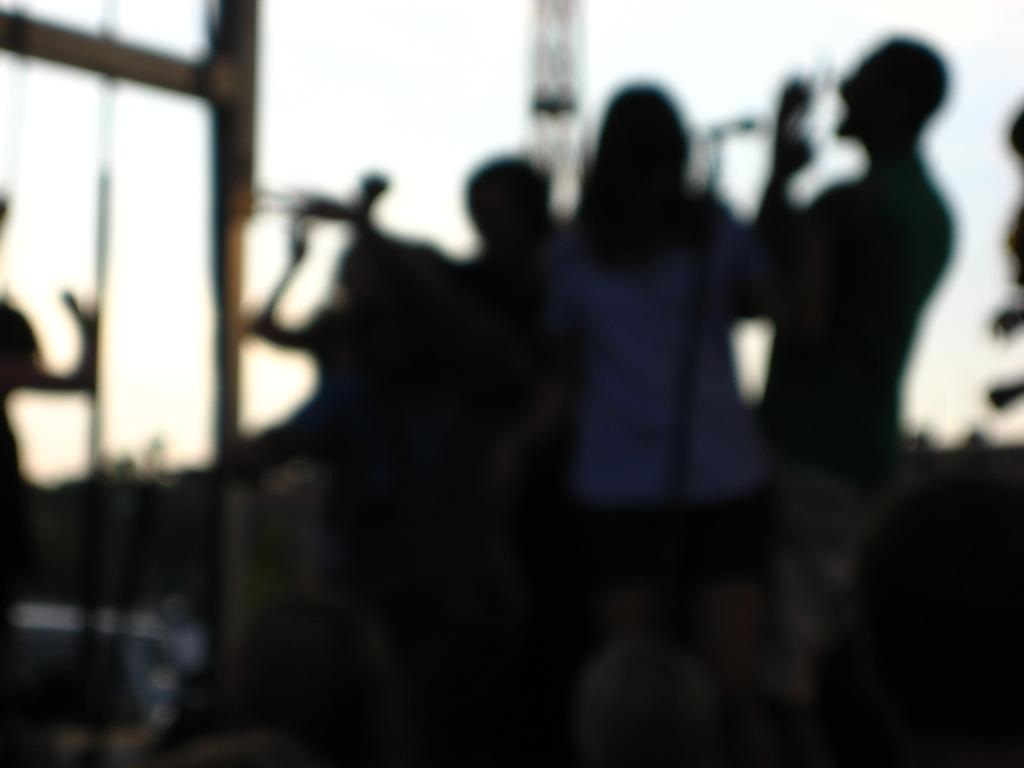How many people are in the image? There are persons in the image, but the exact number is not specified. What object is used for amplifying sound in the image? There is a mic in the image for amplifying sound. What type of structures can be seen in the image? There are poles and a tower in the image. What is visible in the background of the image? The sky is visible in the image. What type of curtain can be seen hanging from the tower in the image? There is no curtain present in the image, and the tower does not have any hanging from it. What can be stored in the can visible in the image? There is no can present in the image. How is the string used in the image? There is no string present in the image. 